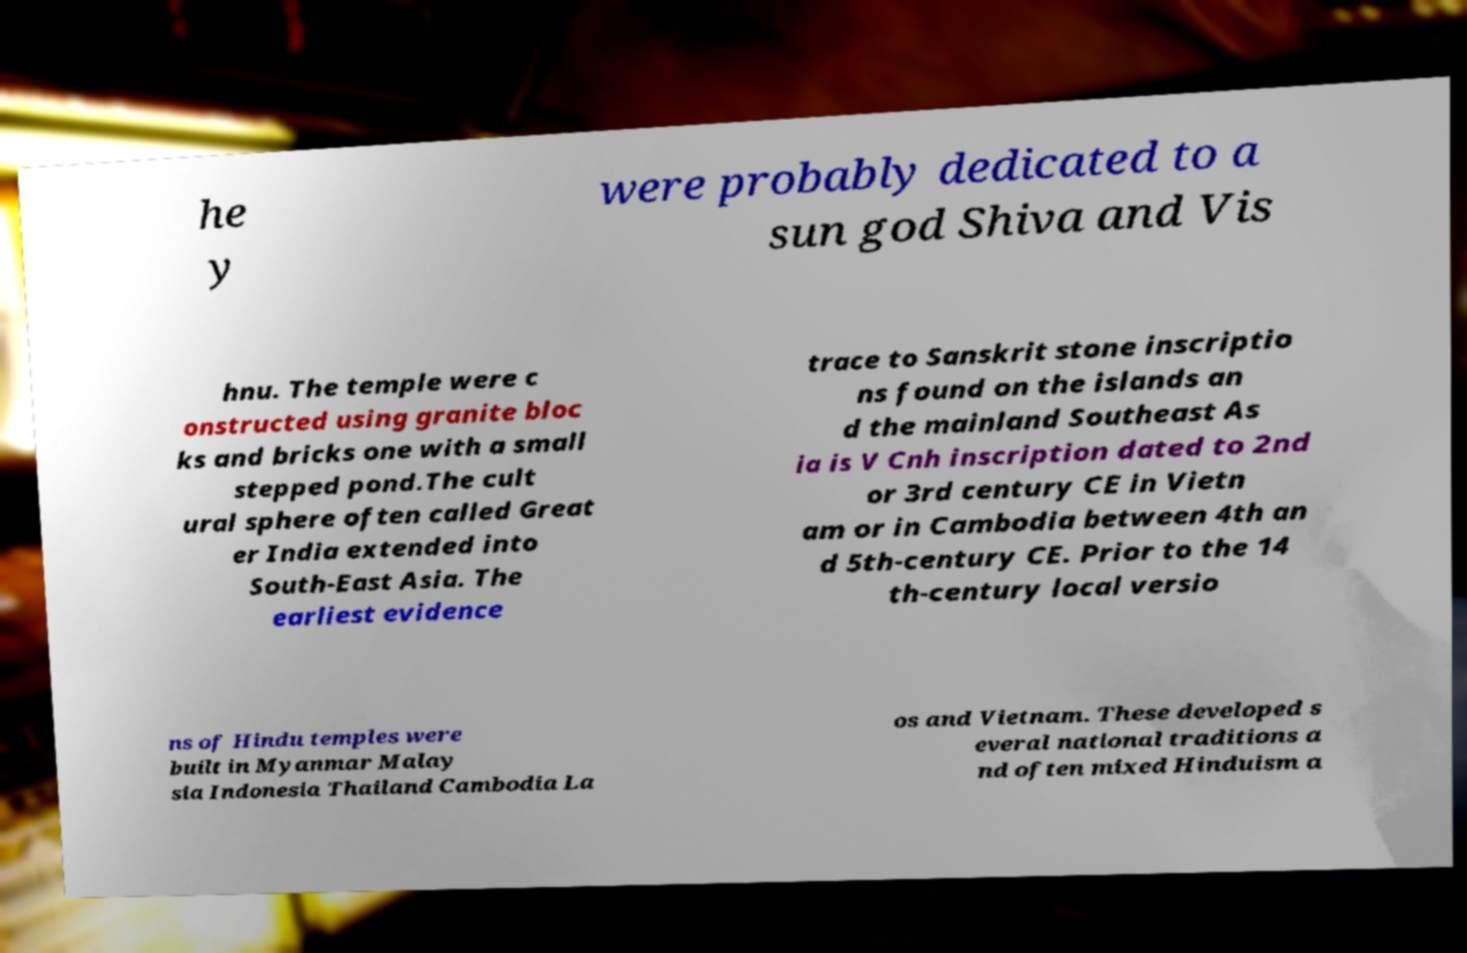There's text embedded in this image that I need extracted. Can you transcribe it verbatim? he y were probably dedicated to a sun god Shiva and Vis hnu. The temple were c onstructed using granite bloc ks and bricks one with a small stepped pond.The cult ural sphere often called Great er India extended into South-East Asia. The earliest evidence trace to Sanskrit stone inscriptio ns found on the islands an d the mainland Southeast As ia is V Cnh inscription dated to 2nd or 3rd century CE in Vietn am or in Cambodia between 4th an d 5th-century CE. Prior to the 14 th-century local versio ns of Hindu temples were built in Myanmar Malay sia Indonesia Thailand Cambodia La os and Vietnam. These developed s everal national traditions a nd often mixed Hinduism a 